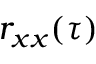<formula> <loc_0><loc_0><loc_500><loc_500>r _ { x x } ( \tau )</formula> 